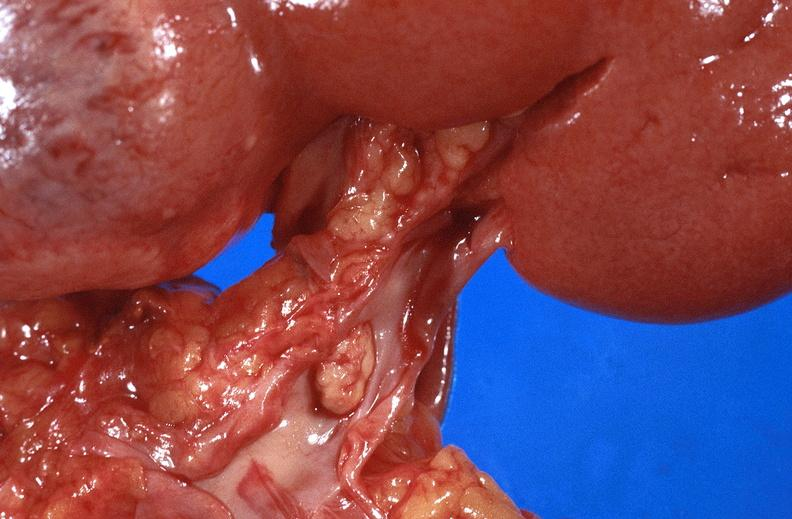where is this?
Answer the question using a single word or phrase. Urinary 